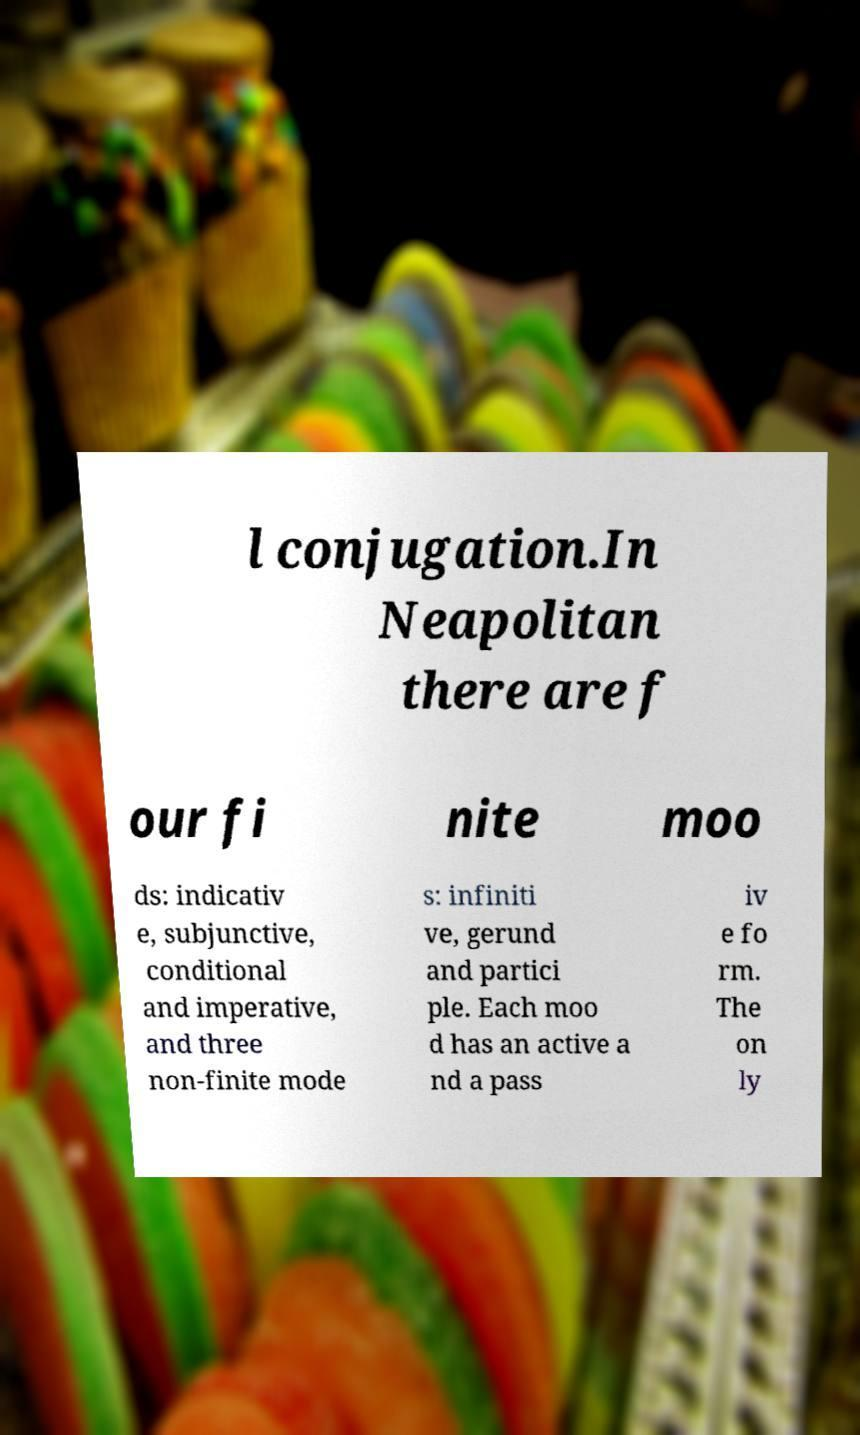Please read and relay the text visible in this image. What does it say? l conjugation.In Neapolitan there are f our fi nite moo ds: indicativ e, subjunctive, conditional and imperative, and three non-finite mode s: infiniti ve, gerund and partici ple. Each moo d has an active a nd a pass iv e fo rm. The on ly 